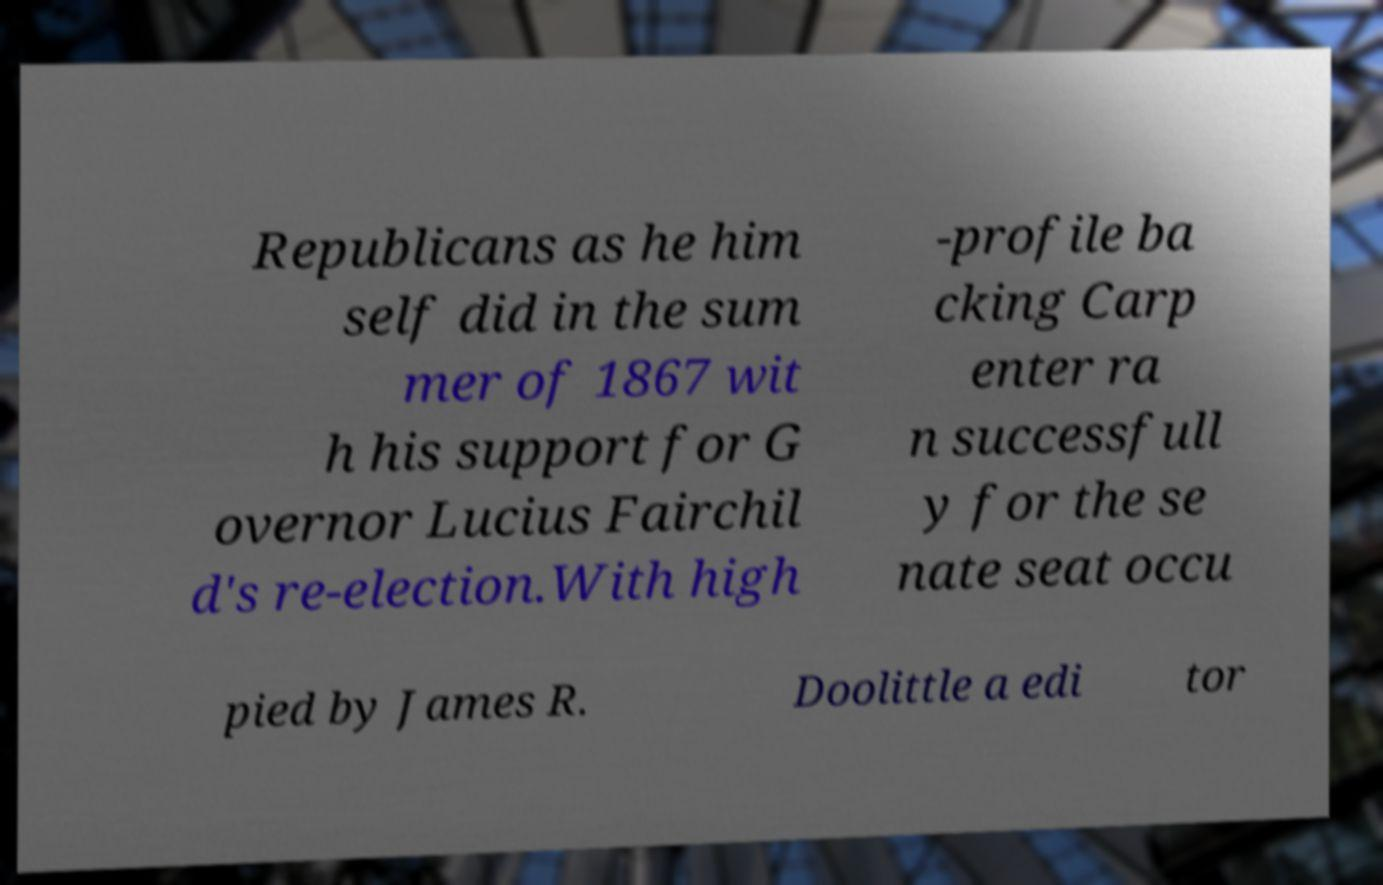Can you accurately transcribe the text from the provided image for me? Republicans as he him self did in the sum mer of 1867 wit h his support for G overnor Lucius Fairchil d's re-election.With high -profile ba cking Carp enter ra n successfull y for the se nate seat occu pied by James R. Doolittle a edi tor 